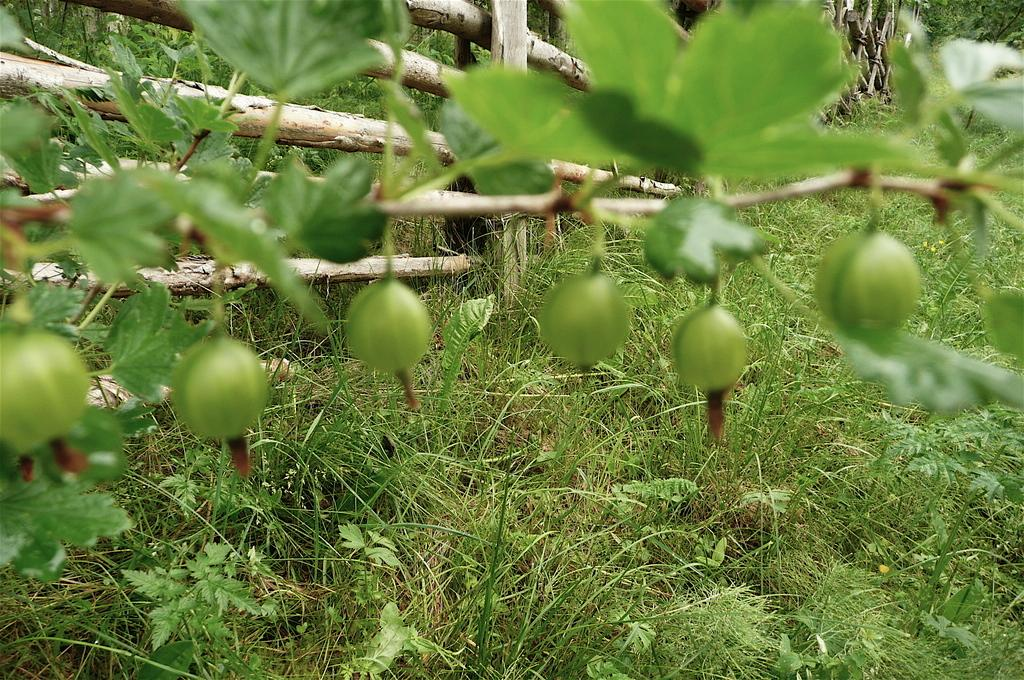What type of landscape is depicted in the image? There is a grassland in the image. What kind of plant can be seen in the image? There is a plant with fruits in the image. What can be seen in the background of the image? There is wooden fencing in the background of the image. What shape is the icicle hanging from the plant in the image? There is no icicle present in the image; it is a plant with fruits, not an icicle. 